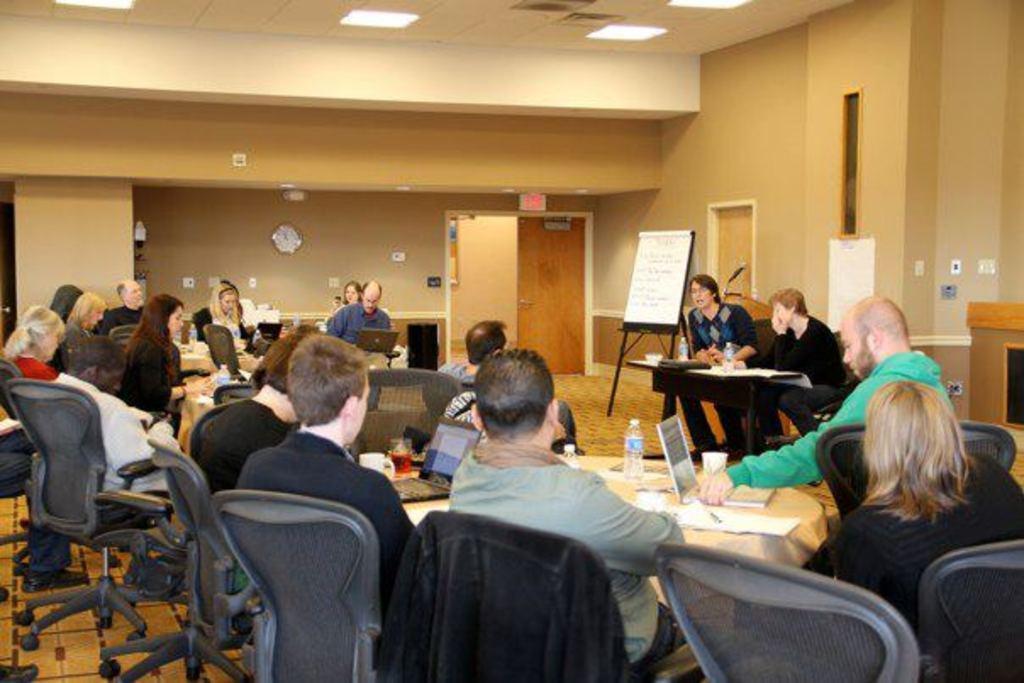How would you summarize this image in a sentence or two? At the top we can see ceiling and lights. We can see a clock over a wall. This is a whiteboard. This is a door. We can see persons sitting on chairs in front of a table and on the table we can see bottle, laptop, glasses, mugs. This is a floor. 